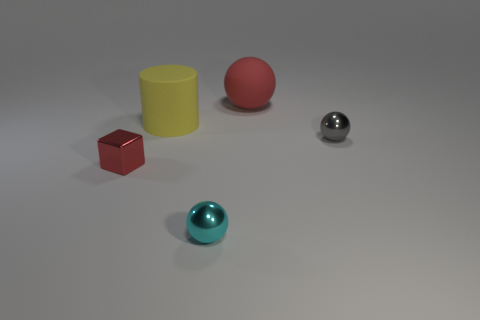Subtract all large red matte spheres. How many spheres are left? 2 Add 3 tiny balls. How many objects exist? 8 Subtract 1 balls. How many balls are left? 2 Add 1 brown rubber cylinders. How many brown rubber cylinders exist? 1 Subtract all red balls. How many balls are left? 2 Subtract 0 brown cylinders. How many objects are left? 5 Subtract all blocks. How many objects are left? 4 Subtract all purple cylinders. Subtract all red spheres. How many cylinders are left? 1 Subtract all brown cubes. Subtract all cyan metallic balls. How many objects are left? 4 Add 3 cyan things. How many cyan things are left? 4 